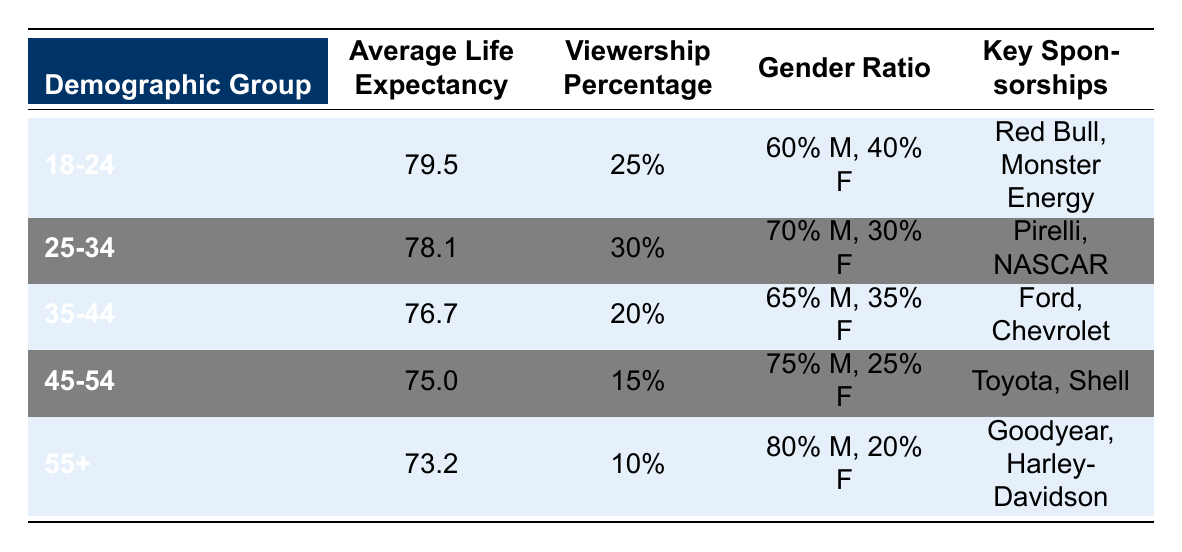What is the average life expectancy for the 45-54 demographic group? From the table, the specific average life expectancy for the 45-54 demographic group is directly listed as 75.0.
Answer: 75.0 Which demographic group has the highest viewership percentage? The highest viewership percentage can be found by comparing the values in that column. The 25-34 group has the highest percentage at 30%.
Answer: 25-34 What is the gender ratio of the 55+ demographic group? The gender ratio is explicitly stated in the 55+ group row, which shows a ratio of 80% Male and 20% Female.
Answer: 80% Male, 20% Female What is the combined viewership percentage of the 18-24 and 25-34 demographic groups? To find the combined viewership percentage, we add the two groups' percentages: 25% (18-24) + 30% (25-34) = 55%.
Answer: 55% Is the average life expectancy for the 35-44 demographic group greater than 76? The average life expectancy for the 35-44 group is listed as 76.7, which is indeed greater than 76.
Answer: Yes What key sponsorships are associated with the 45-54 demographic group? By referencing the table, the key sponsorships listed for the 45-54 group are Toyota and Shell.
Answer: Toyota, Shell Calculate the average life expectancy of all demographic groups. To find the average life expectancy across all groups, sum the average life expectancies: (79.5 + 78.1 + 76.7 + 75.0 + 73.2) = 382.5. The average is then 382.5 / 5 = 76.5.
Answer: 76.5 How many demographic groups have an average life expectancy below 76? By examining the life expectancy values, we identify that the 35-44, 45-54, and 55+ groups all have values below 76, making it three groups.
Answer: 3 What sponsorships are linked to the demographic group with the lowest average life expectancy? The lowest average life expectancy is for the 55+ group, which includes Goodyear and Harley-Davidson as key sponsorships.
Answer: Goodyear, Harley-Davidson 